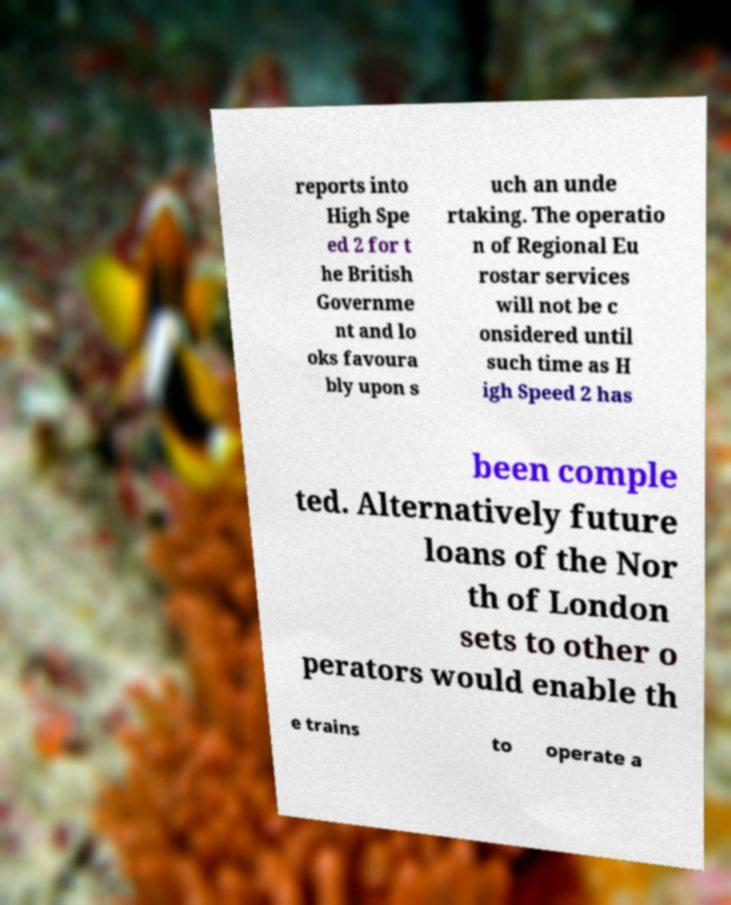Can you read and provide the text displayed in the image?This photo seems to have some interesting text. Can you extract and type it out for me? reports into High Spe ed 2 for t he British Governme nt and lo oks favoura bly upon s uch an unde rtaking. The operatio n of Regional Eu rostar services will not be c onsidered until such time as H igh Speed 2 has been comple ted. Alternatively future loans of the Nor th of London sets to other o perators would enable th e trains to operate a 